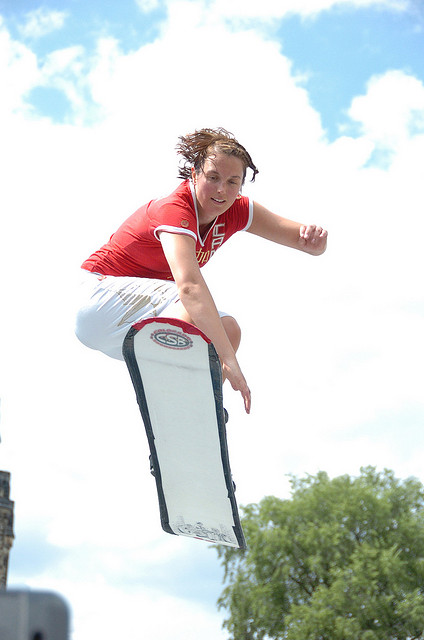<image>What is the shirt written? It is ambiguous what is written on the shirt. It might be 'air', 'cp', or 'red'. What is the shirt written? I am not sure what is written on the shirt. It can be seen 'air', 'cp', 'number' or 'red'. 